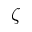Convert formula to latex. <formula><loc_0><loc_0><loc_500><loc_500>\zeta</formula> 